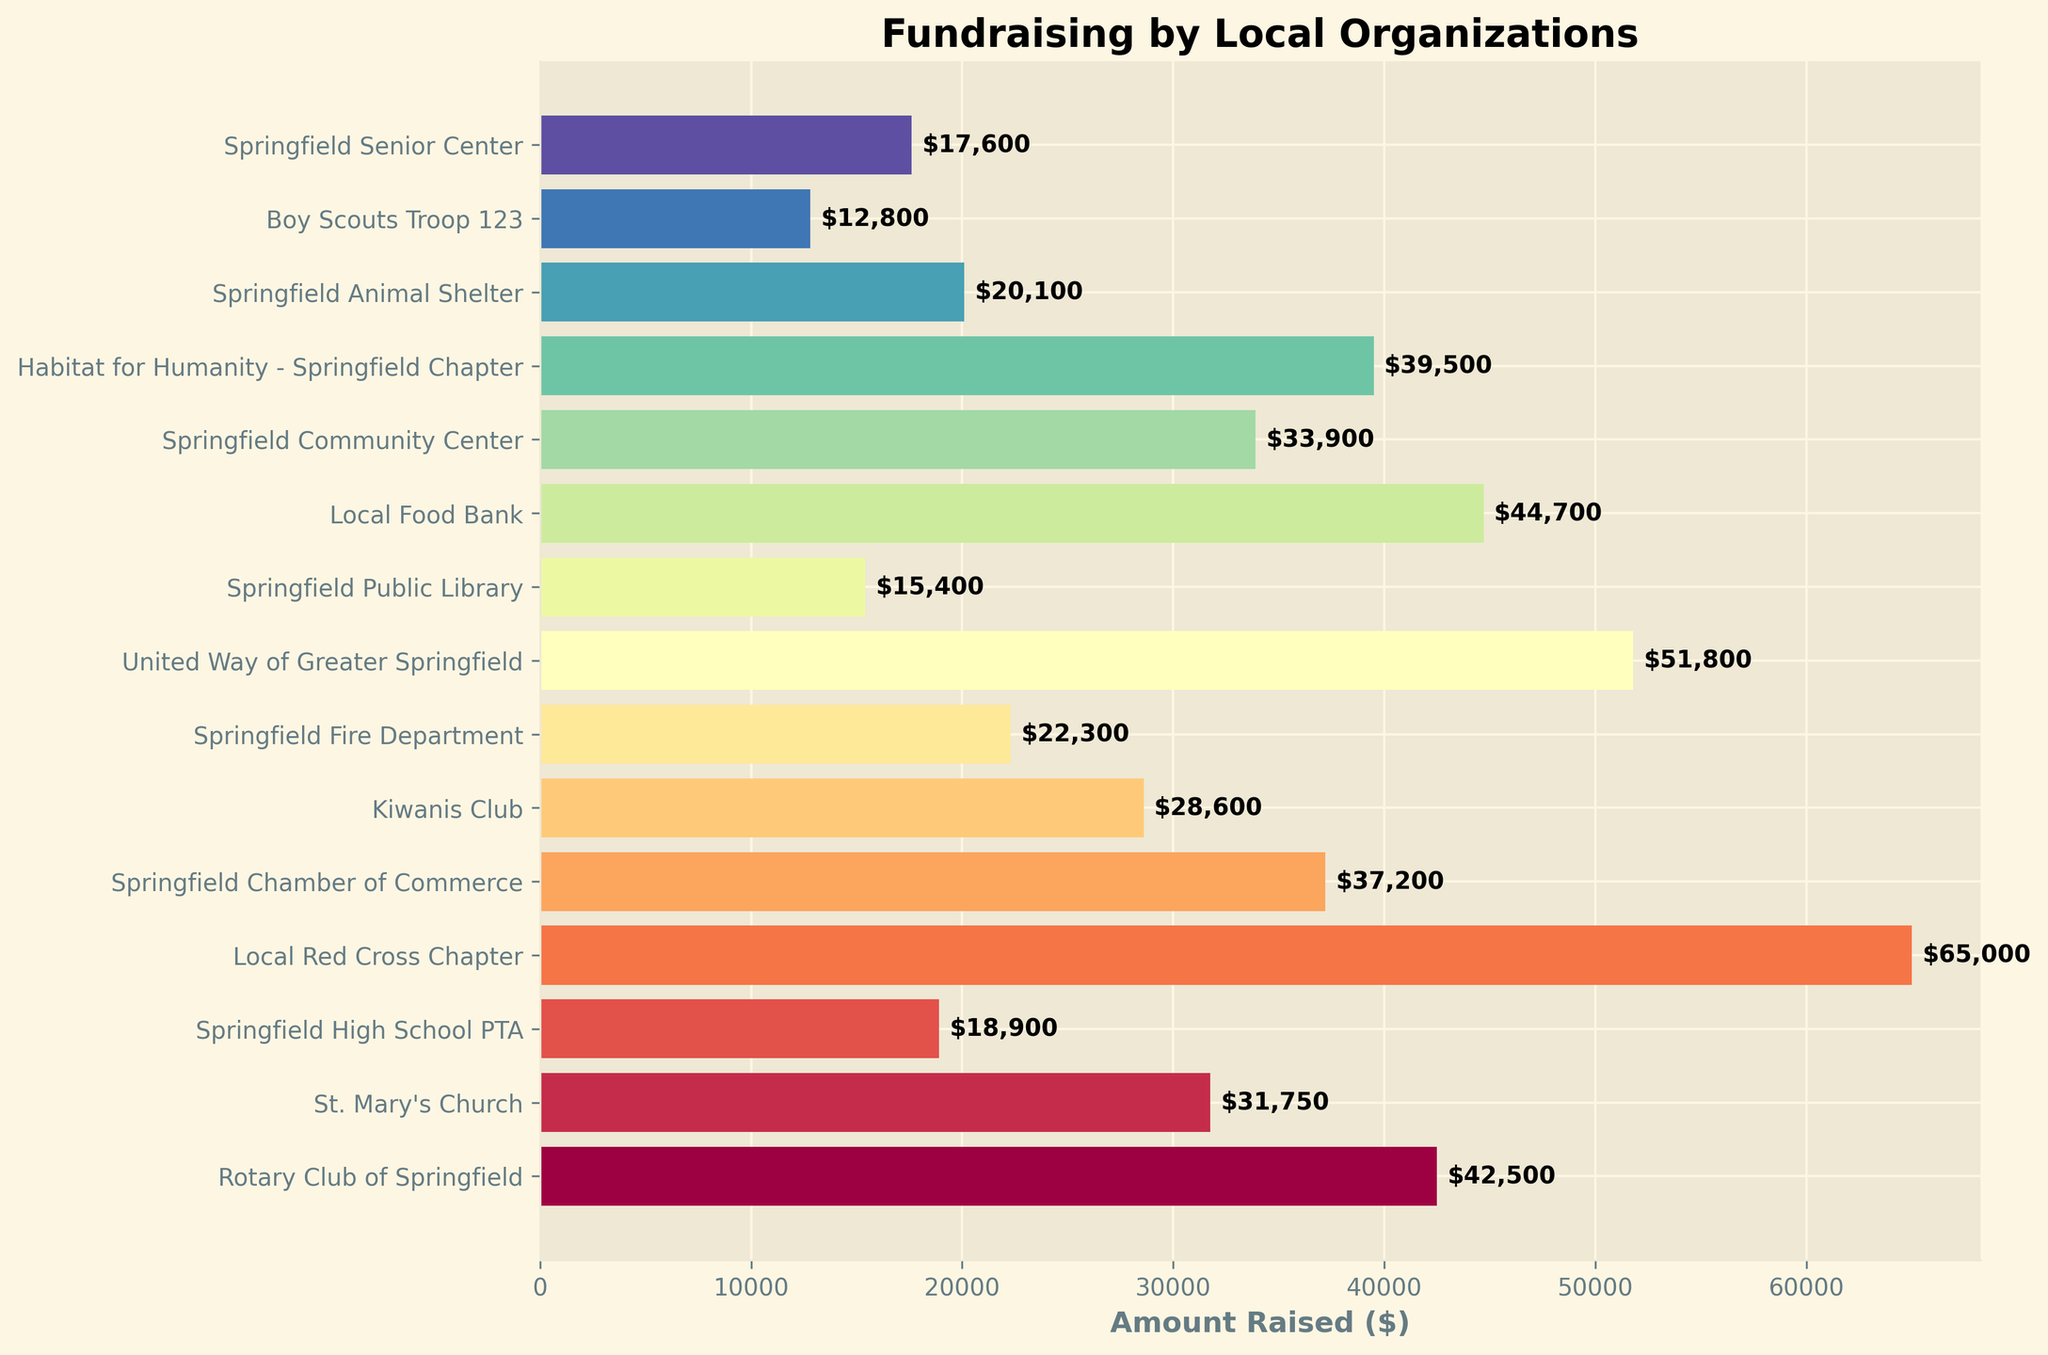What is the total amount raised by the top three organizations? The top three organizations with the highest amounts raised are the Local Red Cross Chapter ($65,000), United Way of Greater Springfield ($51,800), and Local Food Bank ($44,700). Summing these amounts: 65,000 + 51,800 + 44,700 = 161,500
Answer: 161,500 Which organization raised more money: Springfield Fire Department or Springfield Animal Shelter? The Springfield Fire Department raised $22,300, and the Springfield Animal Shelter raised $20,100. Comparing these amounts, $22,300 (Springfield Fire Department) is greater than $20,100 (Springfield Animal Shelter)
Answer: Springfield Fire Department How much more did the Habitat for Humanity - Springfield Chapter raise compared to the Springfield High School PTA? The Habitat for Humanity - Springfield Chapter raised $39,500, and the Springfield High School PTA raised $18,900. Subtracting these amounts: 39,500 - 18,900 = 20,600
Answer: 20,600 What is the average amount raised by all organizations? Adding the amounts raised by all organizations gives the total: 42500 + 31750 + 18900 + 65000 + 37200 + 28600 + 22300 + 51800 + 15400 + 44700 + 33900 + 39500 + 20100 + 12800 + 17600 = 499,450. There are 15 organizations, so the average is 499,450 / 15 = 33,296.67
Answer: 33,296.67 Which organization raised the least amount of money? The organization with the smallest bar on the chart is Boy Scouts Troop 123, which raised $12,800
Answer: Boy Scouts Troop 123 How many organizations raised more than $30,000? The organizations raising more than $30,000 are the Rotary Club of Springfield ($42,500), St. Mary's Church ($31,750), Local Red Cross Chapter ($65,000), Springfield Chamber of Commerce ($37,200), United Way of Greater Springfield ($51,800), Local Food Bank ($44,700), and Habitat for Humanity - Springfield Chapter ($39,500). There are 7 such organizations
Answer: 7 What is the combined amount raised by Springfield Public Library and Springfield Senior Center? The Springfield Public Library raised $15,400, and the Springfield Senior Center raised $17,600. Summing these amounts gives: 15,400 + 17,600 = 33,000
Answer: 33,000 Is the amount raised by Springfield Chamber of Commerce closer to that of Rotary Club of Springfield or Local Food Bank? The Springfield Chamber of Commerce raised $37,200, the Rotary Club of Springfield raised $42,500, and the Local Food Bank raised $44,700. The differences are: 42,500 - 37,200 = 5,300 and 44,700 - 37,200 = 7,500. Springfield Chamber of Commerce is closer to Rotary Club of Springfield by a difference of $5,300 compared to $7,500
Answer: Rotary Club of Springfield What is the median amount raised by the organizations? To find the median, first list the amounts in ascending order: 12,800, 15,400, 17,600, 18,900, 20,100, 22,300, 28,600, 31,750, 33,900, 37,200, 39,500, 42,500, 44,700, 51,800, 65,000. The median is the middle value in this ordered list, which is $31,750 (St. Mary's Church) being the 8th value out of 15
Answer: 31,750 